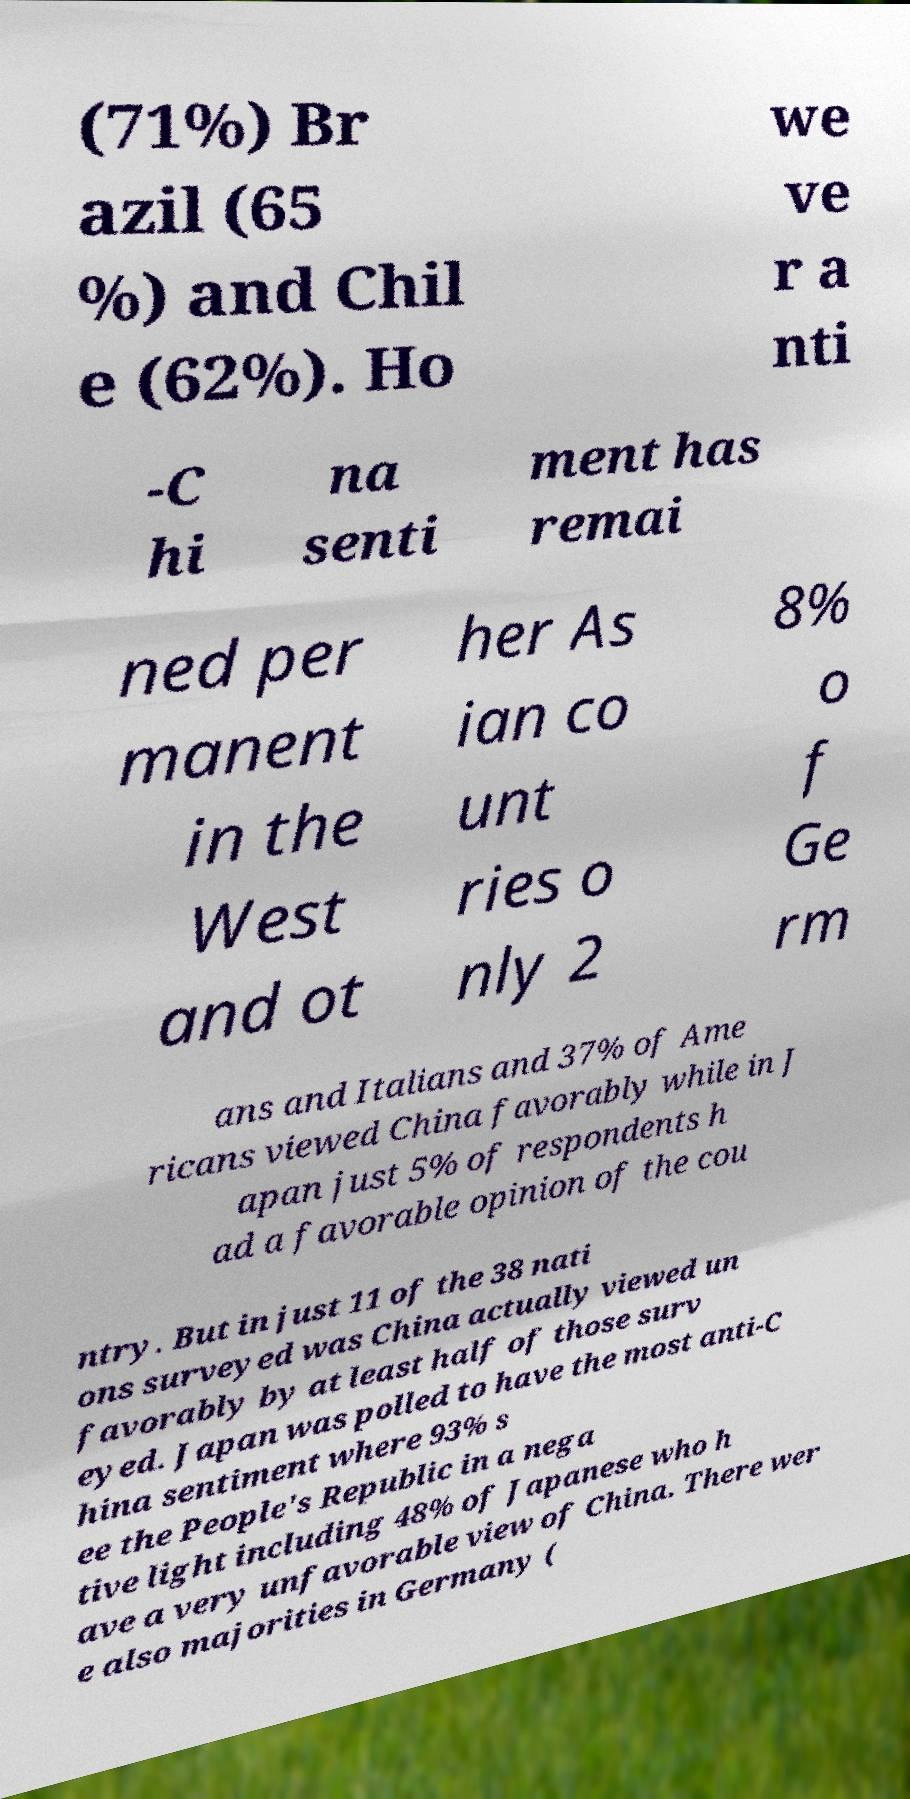Can you accurately transcribe the text from the provided image for me? (71%) Br azil (65 %) and Chil e (62%). Ho we ve r a nti -C hi na senti ment has remai ned per manent in the West and ot her As ian co unt ries o nly 2 8% o f Ge rm ans and Italians and 37% of Ame ricans viewed China favorably while in J apan just 5% of respondents h ad a favorable opinion of the cou ntry. But in just 11 of the 38 nati ons surveyed was China actually viewed un favorably by at least half of those surv eyed. Japan was polled to have the most anti-C hina sentiment where 93% s ee the People's Republic in a nega tive light including 48% of Japanese who h ave a very unfavorable view of China. There wer e also majorities in Germany ( 